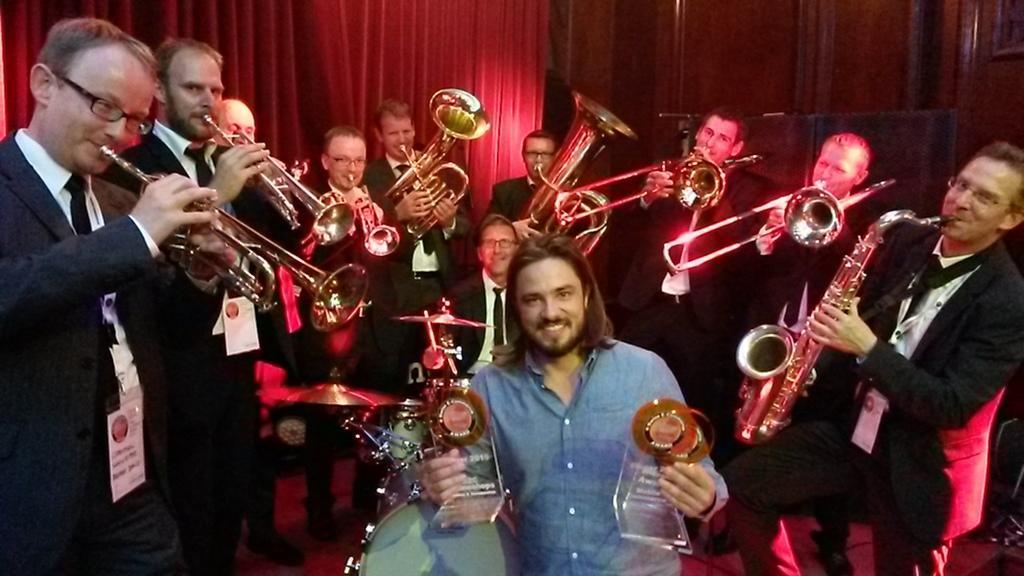In one or two sentences, can you explain what this image depicts? Here I can see a man holding trophies in the hands, smiling and giving pose for the picture. Around him few men are standing and playing some musical instruments. In the background there is a curtain. 